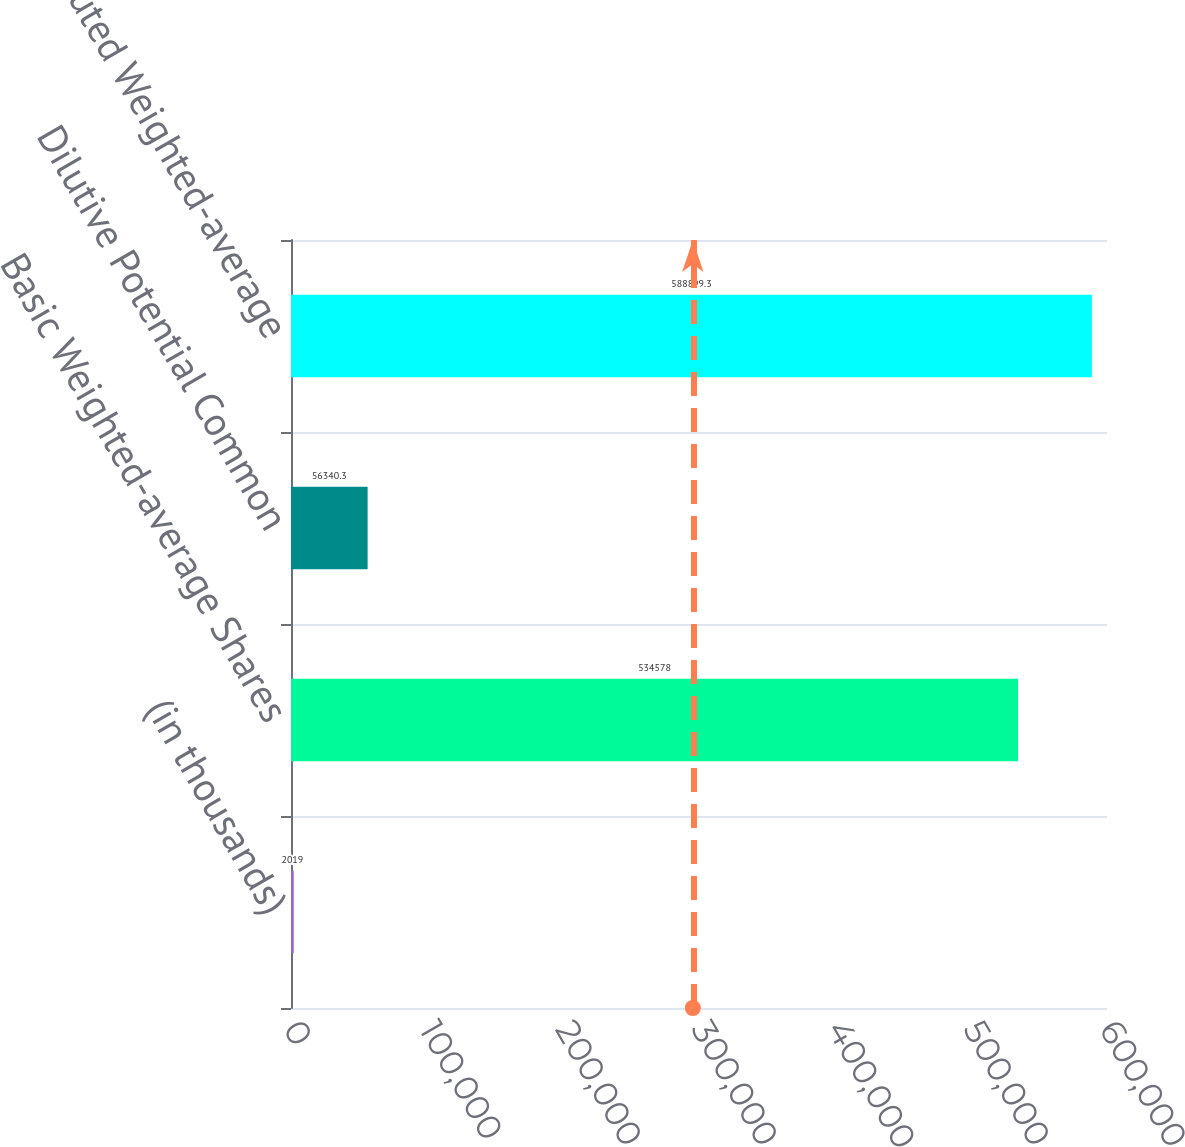<chart> <loc_0><loc_0><loc_500><loc_500><bar_chart><fcel>(in thousands)<fcel>Basic Weighted-average Shares<fcel>Dilutive Potential Common<fcel>Diluted Weighted-average<nl><fcel>2019<fcel>534578<fcel>56340.3<fcel>588899<nl></chart> 